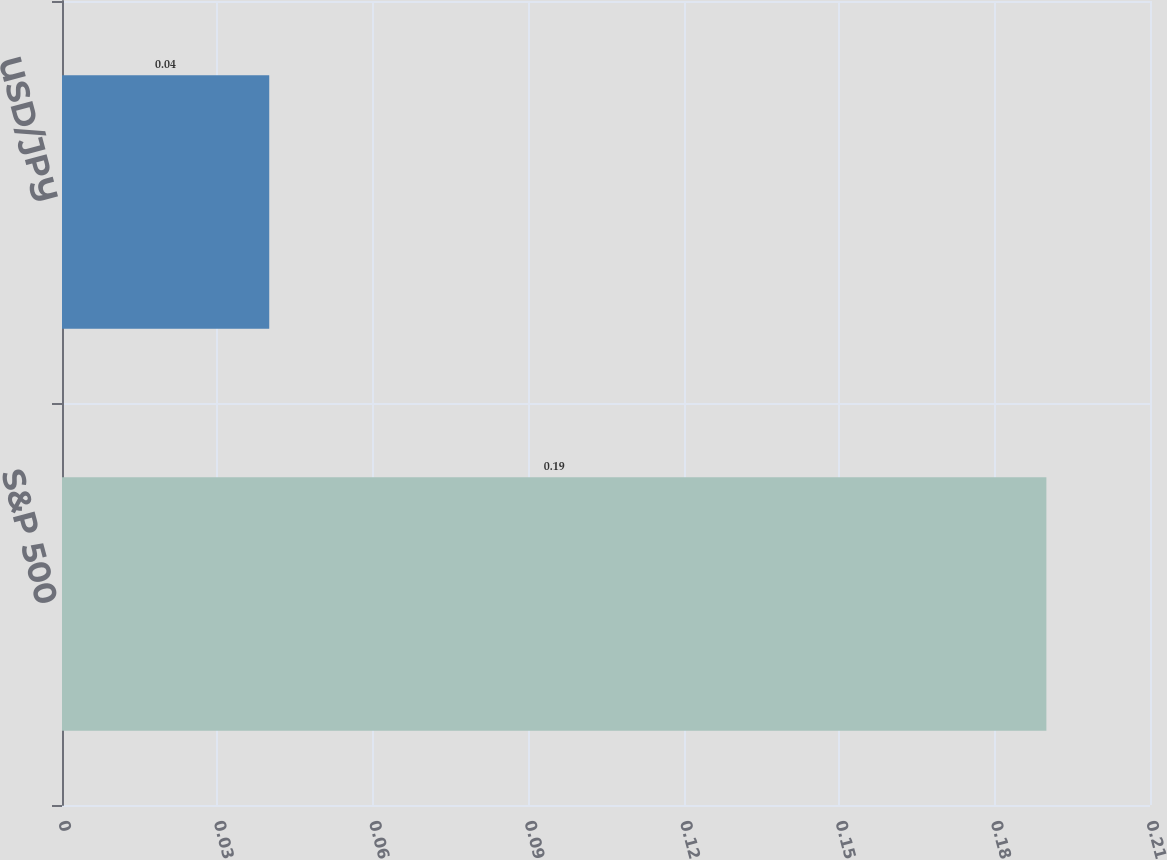<chart> <loc_0><loc_0><loc_500><loc_500><bar_chart><fcel>S&P 500<fcel>USD/JPY<nl><fcel>0.19<fcel>0.04<nl></chart> 